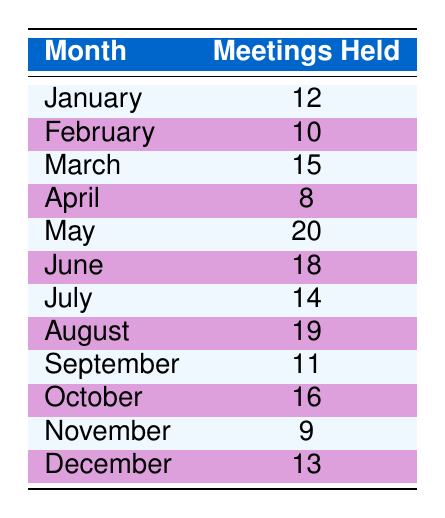What month had the highest number of community meetings? The month with the highest number of meetings is May, which records 20 meetings held.
Answer: May How many meetings were held in February? According to the table, 10 meetings were held in February.
Answer: 10 What is the total number of community meetings held from January to March? Adding the meetings held in January (12), February (10), and March (15) gives a total of 12 + 10 + 15 = 37 meetings.
Answer: 37 Is it true that there were more meetings held in June than in September? Checking the values, June had 18 meetings and September had 11 meetings, so it is true that more meetings were held in June.
Answer: Yes What is the average number of meetings held over the entire year? First, we sum all the meetings: 12 + 10 + 15 + 8 + 20 + 18 + 14 + 19 + 11 + 16 + 9 + 13 =  12 + 10 + 15 + 8 + 20 + 18 + 14 + 19 + 11 + 16 + 9 + 13 = 165. There are 12 months, so the average is 165 / 12 = 13.75.
Answer: 13.75 How many meetings were held in total in April and November combined? The total meetings in April were 8 and in November were 9. Adding these gives 8 + 9 = 17.
Answer: 17 Which month had the lowest number of community meetings? April had the lowest number of meetings, recording only 8 meetings held.
Answer: April Did more meetings occur in the second half of the year (July to December) compared to the first half (January to June)? The total for the second half is 14 + 19 + 11 + 16 + 9 + 13 = 82. The total for the first half is 12 + 10 + 15 + 8 + 20 + 18 = 83. Since 82 is less than 83, it is false that more meetings occurred in the second half.
Answer: No 